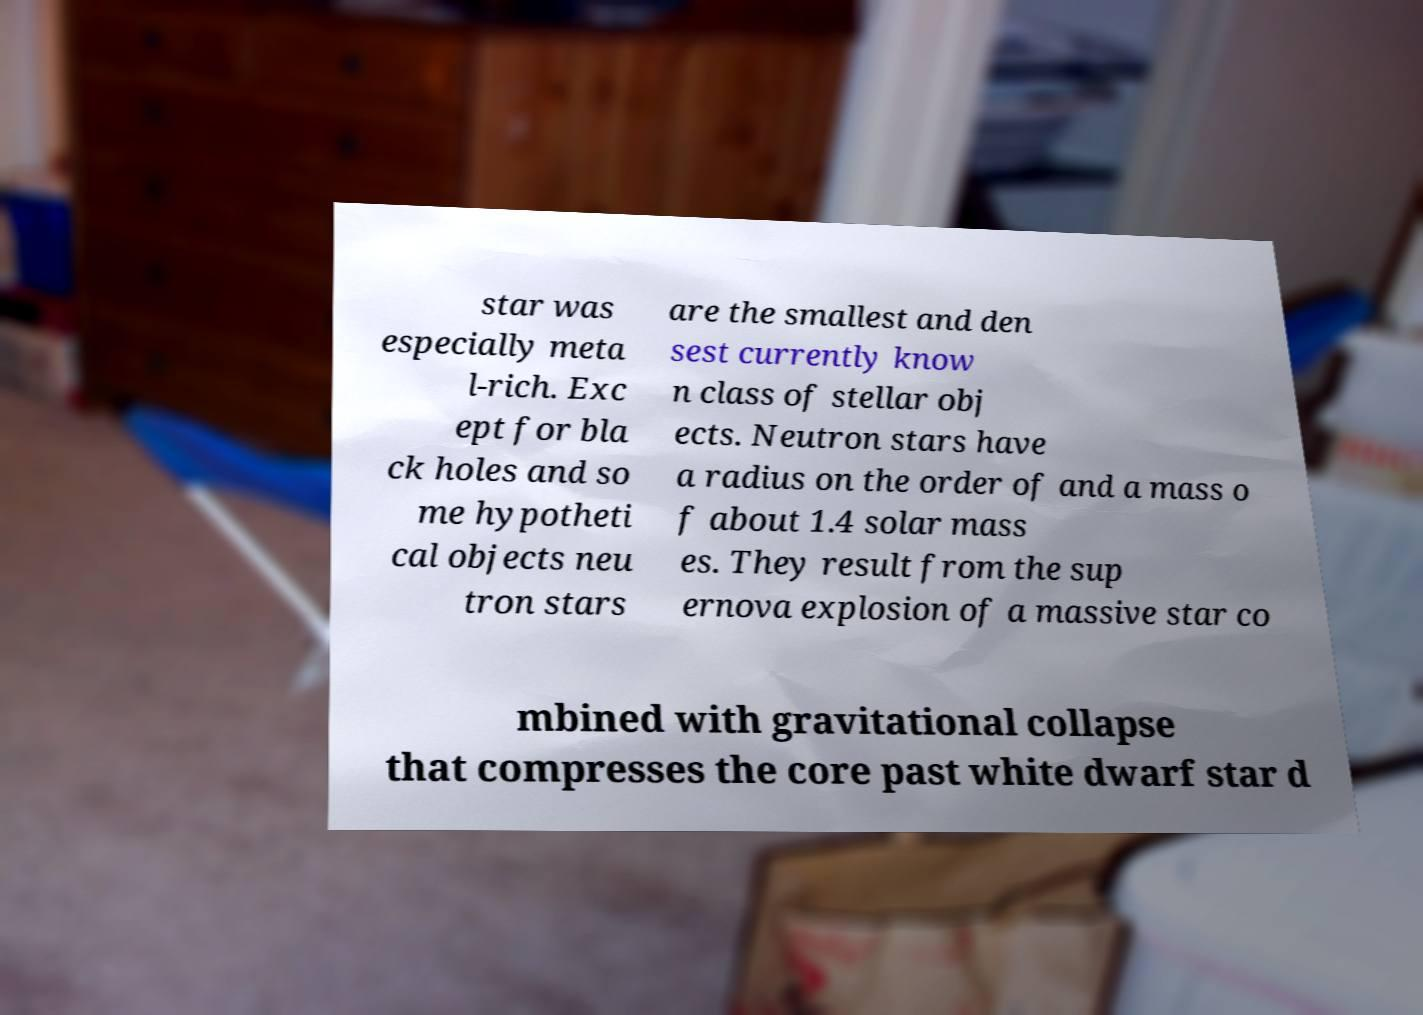Can you accurately transcribe the text from the provided image for me? star was especially meta l-rich. Exc ept for bla ck holes and so me hypotheti cal objects neu tron stars are the smallest and den sest currently know n class of stellar obj ects. Neutron stars have a radius on the order of and a mass o f about 1.4 solar mass es. They result from the sup ernova explosion of a massive star co mbined with gravitational collapse that compresses the core past white dwarf star d 